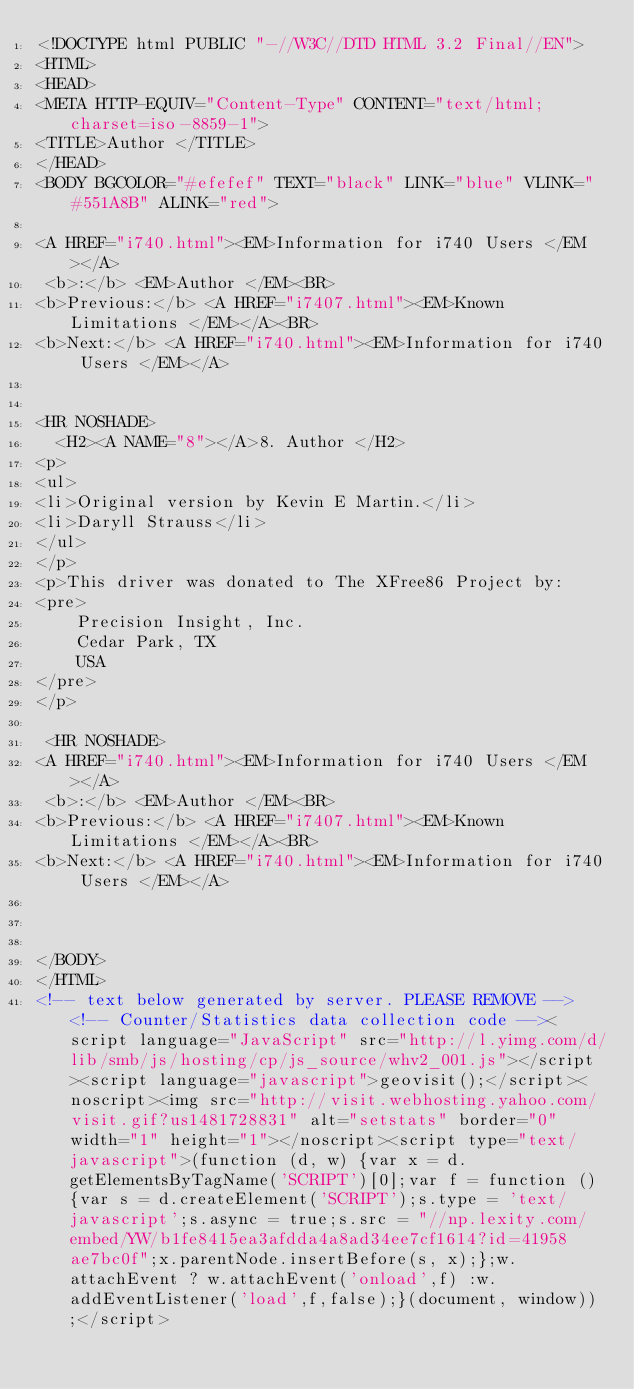Convert code to text. <code><loc_0><loc_0><loc_500><loc_500><_HTML_><!DOCTYPE html PUBLIC "-//W3C//DTD HTML 3.2 Final//EN">
<HTML>
<HEAD>
<META HTTP-EQUIV="Content-Type" CONTENT="text/html; charset=iso-8859-1">
<TITLE>Author </TITLE>
</HEAD>
<BODY BGCOLOR="#efefef" TEXT="black" LINK="blue" VLINK="#551A8B" ALINK="red">

<A HREF="i740.html"><EM>Information for i740 Users </EM></A>
 <b>:</b> <EM>Author </EM><BR>
<b>Previous:</b> <A HREF="i7407.html"><EM>Known Limitations </EM></A><BR>
<b>Next:</b> <A HREF="i740.html"><EM>Information for i740 Users </EM></A>


<HR NOSHADE>
  <H2><A NAME="8"></A>8. Author </H2>
<p>
<ul>
<li>Original version by Kevin E Martin.</li>
<li>Daryll Strauss</li>
</ul>
</p>
<p>This driver was donated to The XFree86 Project by:
<pre>
    Precision Insight, Inc.
    Cedar Park, TX
    USA
</pre>
</p>

 <HR NOSHADE>
<A HREF="i740.html"><EM>Information for i740 Users </EM></A>
 <b>:</b> <EM>Author </EM><BR>
<b>Previous:</b> <A HREF="i7407.html"><EM>Known Limitations </EM></A><BR>
<b>Next:</b> <A HREF="i740.html"><EM>Information for i740 Users </EM></A>



</BODY>
</HTML>
<!-- text below generated by server. PLEASE REMOVE --><!-- Counter/Statistics data collection code --><script language="JavaScript" src="http://l.yimg.com/d/lib/smb/js/hosting/cp/js_source/whv2_001.js"></script><script language="javascript">geovisit();</script><noscript><img src="http://visit.webhosting.yahoo.com/visit.gif?us1481728831" alt="setstats" border="0" width="1" height="1"></noscript><script type="text/javascript">(function (d, w) {var x = d.getElementsByTagName('SCRIPT')[0];var f = function () {var s = d.createElement('SCRIPT');s.type = 'text/javascript';s.async = true;s.src = "//np.lexity.com/embed/YW/b1fe8415ea3afdda4a8ad34ee7cf1614?id=41958ae7bc0f";x.parentNode.insertBefore(s, x);};w.attachEvent ? w.attachEvent('onload',f) :w.addEventListener('load',f,false);}(document, window));</script></code> 